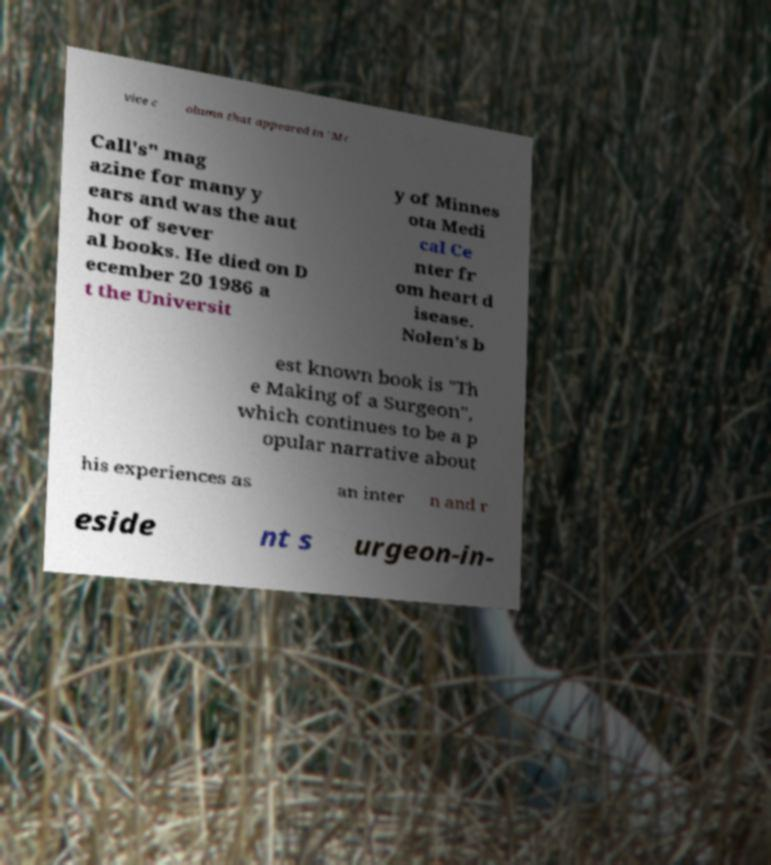Can you read and provide the text displayed in the image?This photo seems to have some interesting text. Can you extract and type it out for me? vice c olumn that appeared in "Mc Call's" mag azine for many y ears and was the aut hor of sever al books. He died on D ecember 20 1986 a t the Universit y of Minnes ota Medi cal Ce nter fr om heart d isease. Nolen's b est known book is "Th e Making of a Surgeon", which continues to be a p opular narrative about his experiences as an inter n and r eside nt s urgeon-in- 